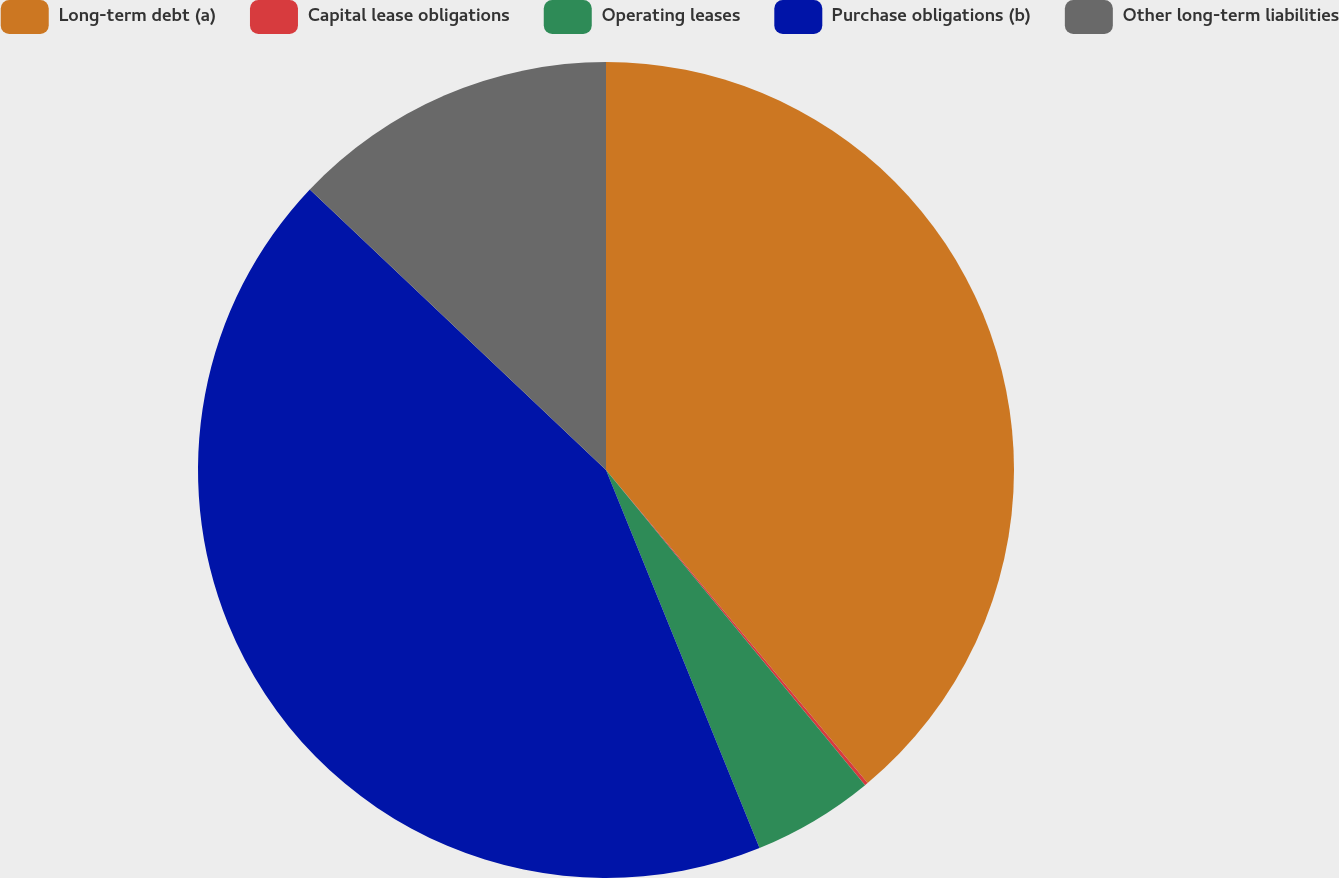Convert chart. <chart><loc_0><loc_0><loc_500><loc_500><pie_chart><fcel>Long-term debt (a)<fcel>Capital lease obligations<fcel>Operating leases<fcel>Purchase obligations (b)<fcel>Other long-term liabilities<nl><fcel>38.92%<fcel>0.13%<fcel>4.81%<fcel>43.21%<fcel>12.93%<nl></chart> 